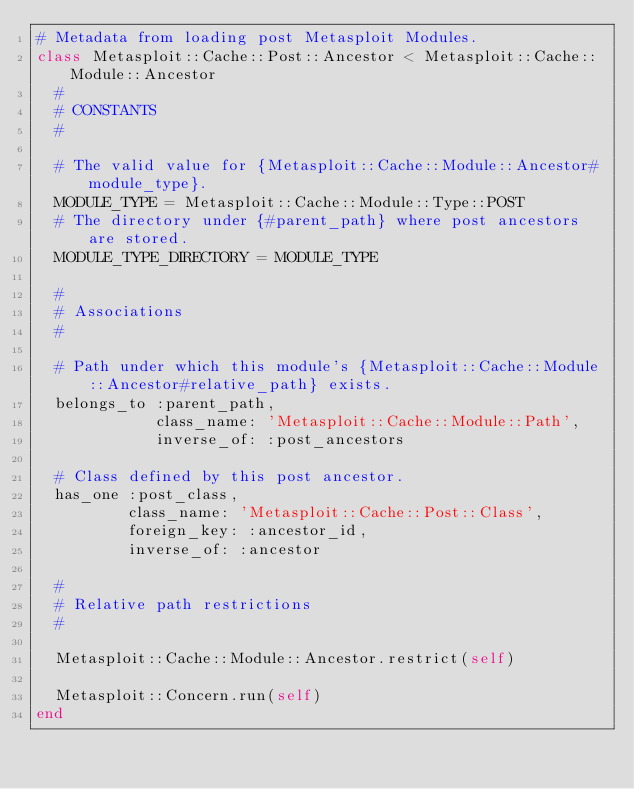<code> <loc_0><loc_0><loc_500><loc_500><_Ruby_># Metadata from loading post Metasploit Modules.
class Metasploit::Cache::Post::Ancestor < Metasploit::Cache::Module::Ancestor
  #
  # CONSTANTS
  #

  # The valid value for {Metasploit::Cache::Module::Ancestor#module_type}.
  MODULE_TYPE = Metasploit::Cache::Module::Type::POST
  # The directory under {#parent_path} where post ancestors are stored.
  MODULE_TYPE_DIRECTORY = MODULE_TYPE

  #
  # Associations
  #

  # Path under which this module's {Metasploit::Cache::Module::Ancestor#relative_path} exists.
  belongs_to :parent_path,
             class_name: 'Metasploit::Cache::Module::Path',
             inverse_of: :post_ancestors

  # Class defined by this post ancestor.
  has_one :post_class,
          class_name: 'Metasploit::Cache::Post::Class',
          foreign_key: :ancestor_id,
          inverse_of: :ancestor

  #
  # Relative path restrictions
  #

  Metasploit::Cache::Module::Ancestor.restrict(self)

  Metasploit::Concern.run(self)
end</code> 